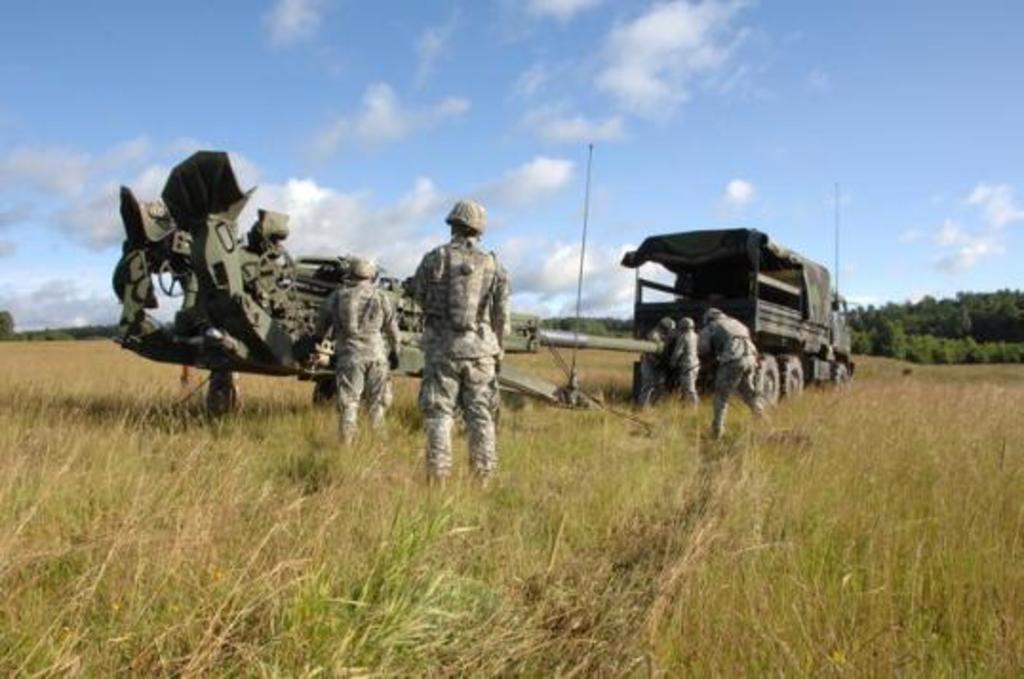How would you summarize this image in a sentence or two? There are army soldiers, they are fixing the machine gun to a vehicle and around them there is a lot of grass and behind the grass there are a lot of trees, in the background there is a sky. 